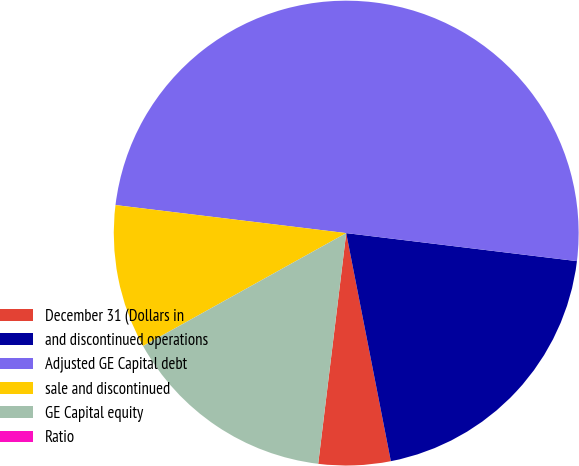Convert chart to OTSL. <chart><loc_0><loc_0><loc_500><loc_500><pie_chart><fcel>December 31 (Dollars in<fcel>and discontinued operations<fcel>Adjusted GE Capital debt<fcel>sale and discontinued<fcel>GE Capital equity<fcel>Ratio<nl><fcel>5.0%<fcel>20.0%<fcel>50.0%<fcel>10.0%<fcel>15.0%<fcel>0.0%<nl></chart> 